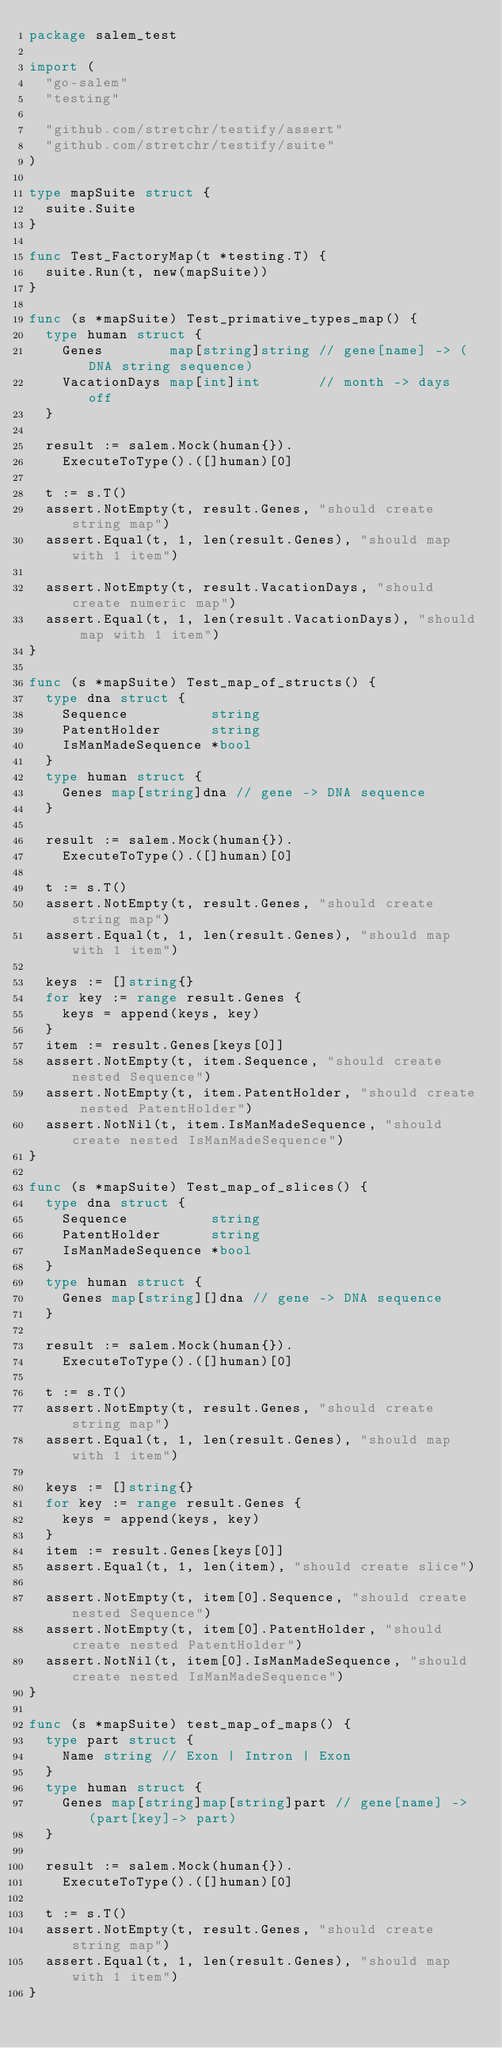Convert code to text. <code><loc_0><loc_0><loc_500><loc_500><_Go_>package salem_test

import (
	"go-salem"
	"testing"

	"github.com/stretchr/testify/assert"
	"github.com/stretchr/testify/suite"
)

type mapSuite struct {
	suite.Suite
}

func Test_FactoryMap(t *testing.T) {
	suite.Run(t, new(mapSuite))
}

func (s *mapSuite) Test_primative_types_map() {
	type human struct {
		Genes        map[string]string // gene[name] -> (DNA string sequence)
		VacationDays map[int]int       // month -> days off
	}

	result := salem.Mock(human{}).
		ExecuteToType().([]human)[0]

	t := s.T()
	assert.NotEmpty(t, result.Genes, "should create string map")
	assert.Equal(t, 1, len(result.Genes), "should map with 1 item")

	assert.NotEmpty(t, result.VacationDays, "should create numeric map")
	assert.Equal(t, 1, len(result.VacationDays), "should map with 1 item")
}

func (s *mapSuite) Test_map_of_structs() {
	type dna struct {
		Sequence          string
		PatentHolder      string
		IsManMadeSequence *bool
	}
	type human struct {
		Genes map[string]dna // gene -> DNA sequence
	}

	result := salem.Mock(human{}).
		ExecuteToType().([]human)[0]

	t := s.T()
	assert.NotEmpty(t, result.Genes, "should create string map")
	assert.Equal(t, 1, len(result.Genes), "should map with 1 item")

	keys := []string{}
	for key := range result.Genes {
		keys = append(keys, key)
	}
	item := result.Genes[keys[0]]
	assert.NotEmpty(t, item.Sequence, "should create nested Sequence")
	assert.NotEmpty(t, item.PatentHolder, "should create nested PatentHolder")
	assert.NotNil(t, item.IsManMadeSequence, "should create nested IsManMadeSequence")
}

func (s *mapSuite) Test_map_of_slices() {
	type dna struct {
		Sequence          string
		PatentHolder      string
		IsManMadeSequence *bool
	}
	type human struct {
		Genes map[string][]dna // gene -> DNA sequence
	}

	result := salem.Mock(human{}).
		ExecuteToType().([]human)[0]

	t := s.T()
	assert.NotEmpty(t, result.Genes, "should create string map")
	assert.Equal(t, 1, len(result.Genes), "should map with 1 item")

	keys := []string{}
	for key := range result.Genes {
		keys = append(keys, key)
	}
	item := result.Genes[keys[0]]
	assert.Equal(t, 1, len(item), "should create slice")

	assert.NotEmpty(t, item[0].Sequence, "should create nested Sequence")
	assert.NotEmpty(t, item[0].PatentHolder, "should create nested PatentHolder")
	assert.NotNil(t, item[0].IsManMadeSequence, "should create nested IsManMadeSequence")
}

func (s *mapSuite) test_map_of_maps() {
	type part struct {
		Name string // Exon | Intron | Exon
	}
	type human struct {
		Genes map[string]map[string]part // gene[name] -> (part[key]-> part)
	}

	result := salem.Mock(human{}).
		ExecuteToType().([]human)[0]

	t := s.T()
	assert.NotEmpty(t, result.Genes, "should create string map")
	assert.Equal(t, 1, len(result.Genes), "should map with 1 item")
}
</code> 